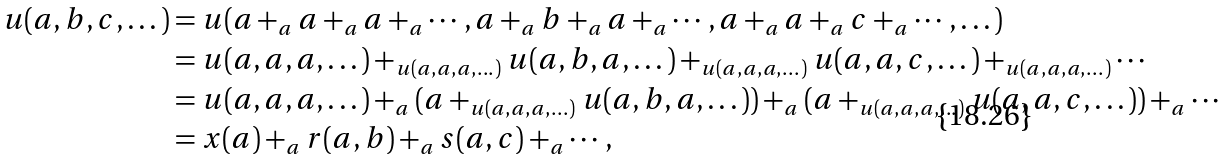Convert formula to latex. <formula><loc_0><loc_0><loc_500><loc_500>u ( a , b , c , \dots ) & = u ( a + _ { a } a + _ { a } a + _ { a } \cdots , a + _ { a } b + _ { a } a + _ { a } \cdots , a + _ { a } a + _ { a } c + _ { a } \cdots , \dots ) \\ & = u ( a , a , a , \dots ) + _ { u ( a , a , a , \dots ) } u ( a , b , a , \dots ) + _ { u ( a , a , a , \dots ) } u ( a , a , c , \dots ) + _ { u ( a , a , a , \dots ) } \cdots \\ & = u ( a , a , a , \dots ) + _ { a } ( a + _ { u ( a , a , a , \dots ) } u ( a , b , a , \dots ) ) + _ { a } ( a + _ { u ( a , a , a , \dots ) } u ( a , a , c , \dots ) ) + _ { a } \cdots \\ & = x ( a ) + _ { a } r ( a , b ) + _ { a } s ( a , c ) + _ { a } \cdots ,</formula> 